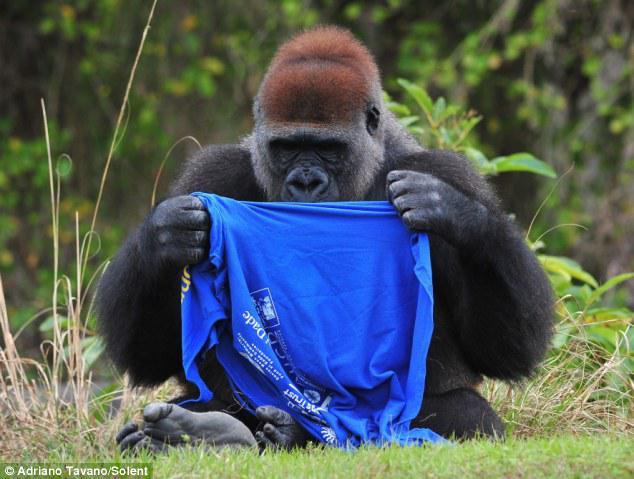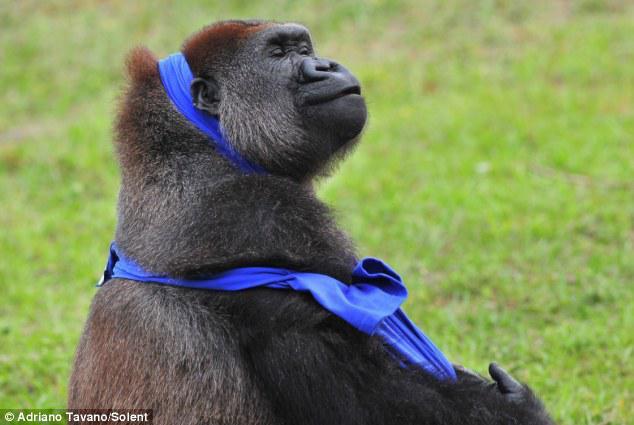The first image is the image on the left, the second image is the image on the right. Examine the images to the left and right. Is the description "A gorilla is shown with an item of clothing in each image." accurate? Answer yes or no. Yes. The first image is the image on the left, the second image is the image on the right. Considering the images on both sides, is "the left and right image contains the same number of gorillas with human clothing." valid? Answer yes or no. Yes. 